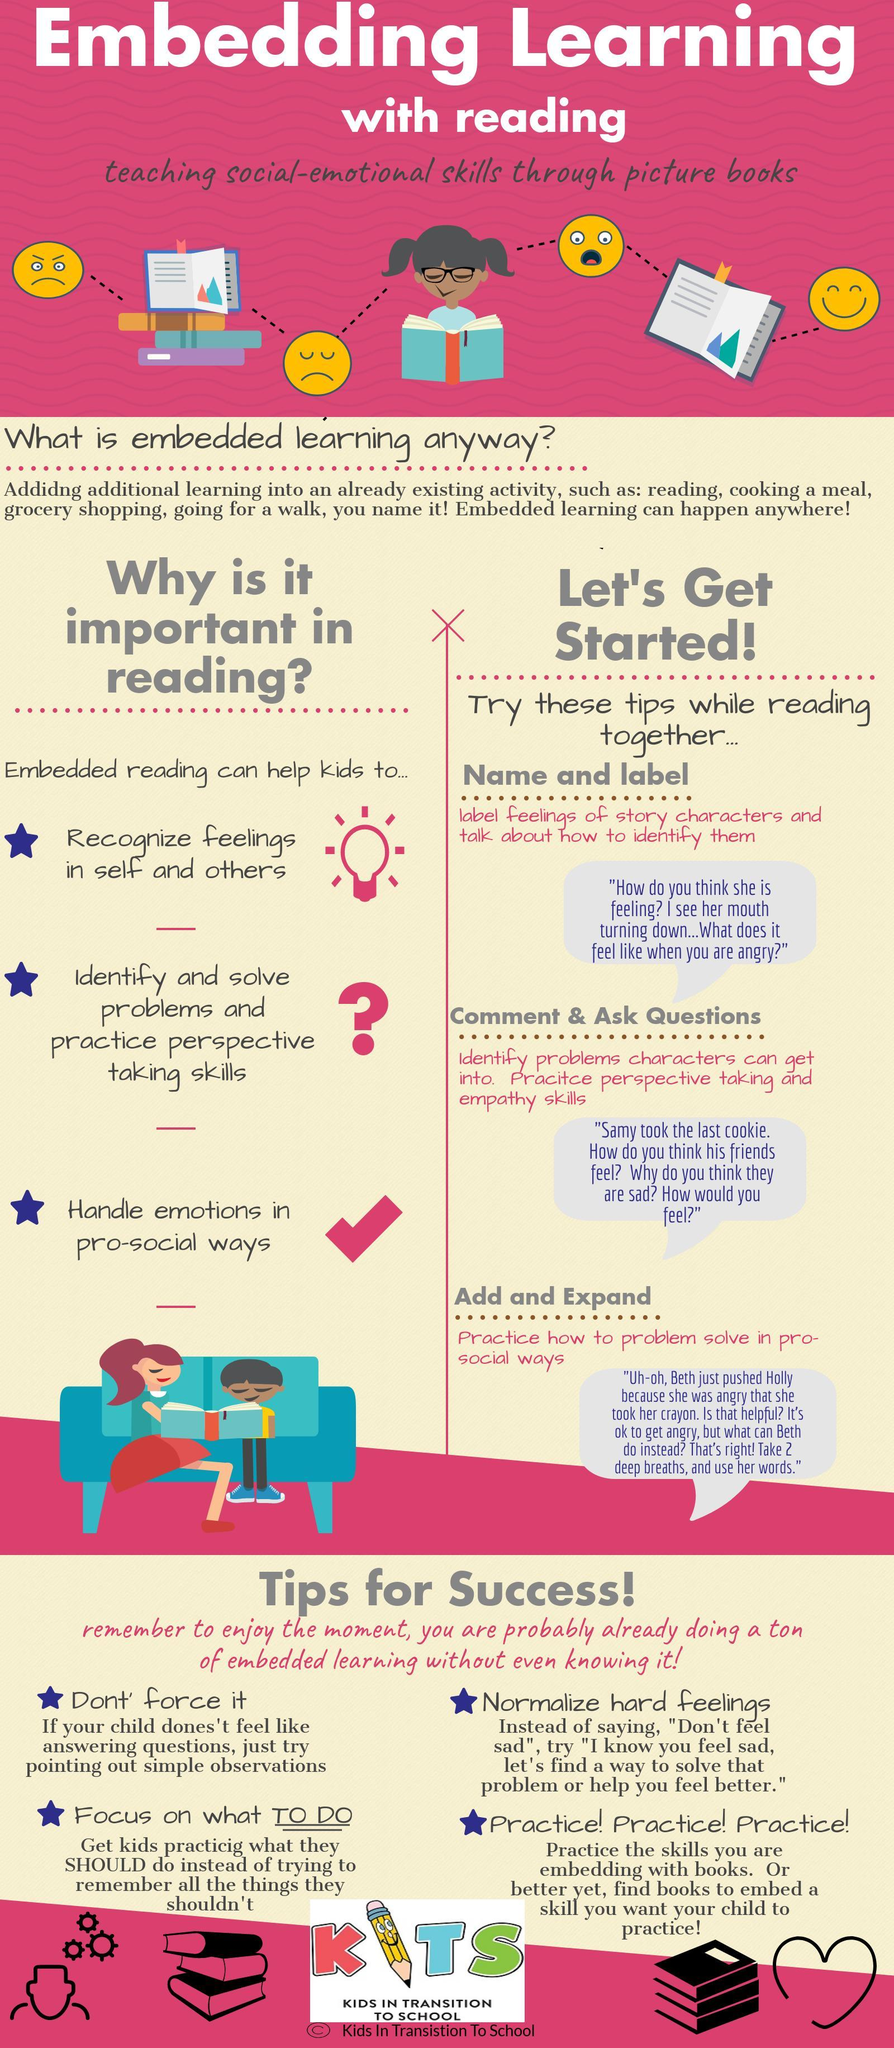What is listed first as the benefit of embedded reading?
Answer the question with a short phrase. recognize feelings in self and others What is listed third as the benefit of embedded reading? handle emotions in pro-social ways What is listed second as the benefit of embedded reading? identify and solve problems and practice perspective taking skills 